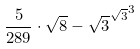Convert formula to latex. <formula><loc_0><loc_0><loc_500><loc_500>\frac { 5 } { 2 8 9 } \cdot \sqrt { 8 } - { \sqrt { 3 } ^ { \sqrt { 3 } } } ^ { 3 }</formula> 